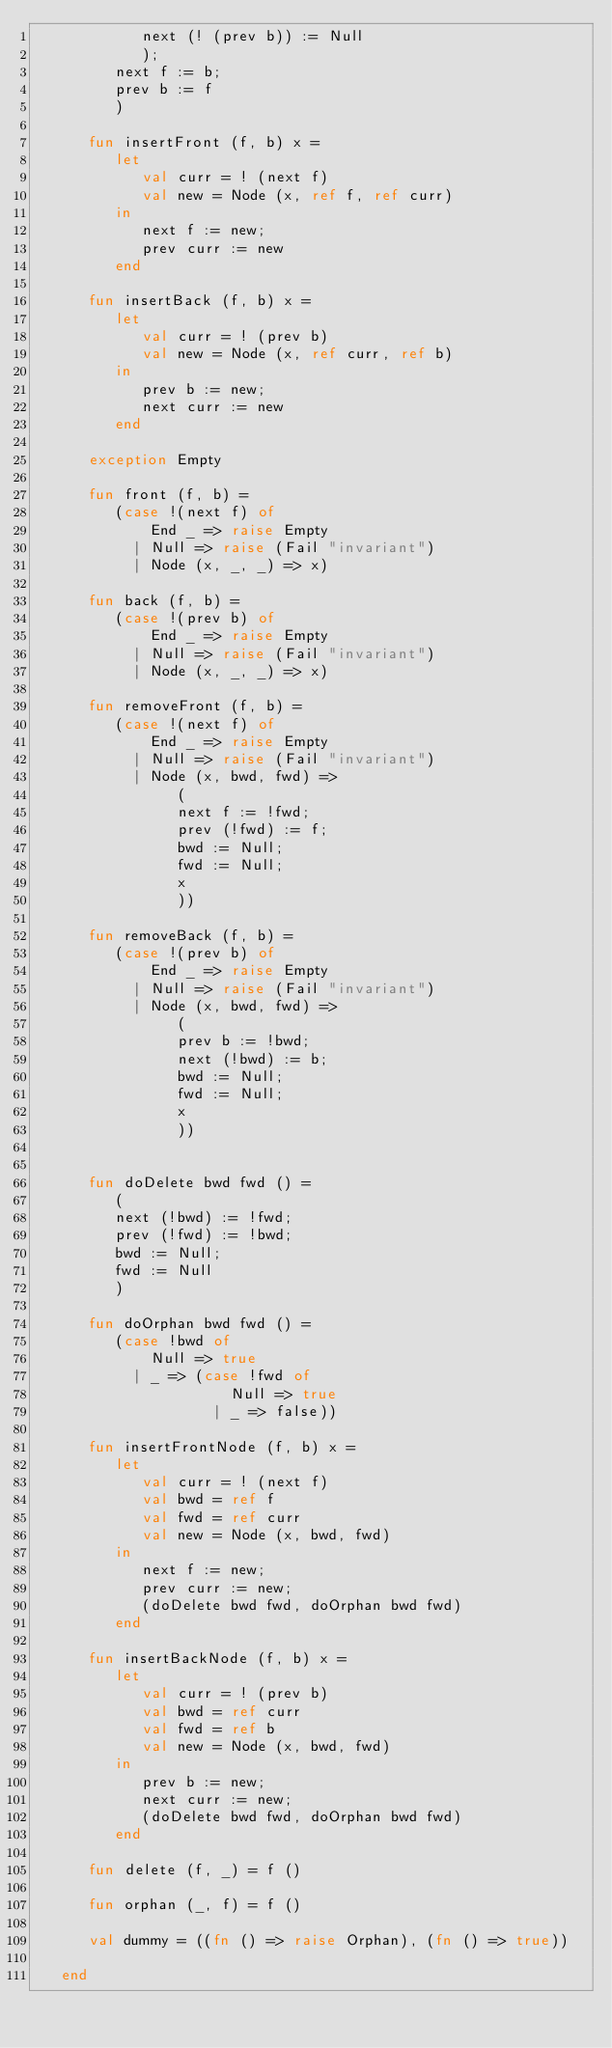<code> <loc_0><loc_0><loc_500><loc_500><_SML_>            next (! (prev b)) := Null
            );
         next f := b;
         prev b := f
         )
         
      fun insertFront (f, b) x =
         let
            val curr = ! (next f)
            val new = Node (x, ref f, ref curr)
         in
            next f := new;
            prev curr := new
         end

      fun insertBack (f, b) x =
         let
            val curr = ! (prev b)
            val new = Node (x, ref curr, ref b)
         in
            prev b := new;
            next curr := new
         end

      exception Empty

      fun front (f, b) =
         (case !(next f) of
             End _ => raise Empty
           | Null => raise (Fail "invariant")
           | Node (x, _, _) => x)

      fun back (f, b) =
         (case !(prev b) of
             End _ => raise Empty
           | Null => raise (Fail "invariant")
           | Node (x, _, _) => x)

      fun removeFront (f, b) =
         (case !(next f) of
             End _ => raise Empty
           | Null => raise (Fail "invariant")
           | Node (x, bwd, fwd) =>
                (
                next f := !fwd;
                prev (!fwd) := f;
                bwd := Null;
                fwd := Null;
                x
                ))

      fun removeBack (f, b) =
         (case !(prev b) of
             End _ => raise Empty
           | Null => raise (Fail "invariant")
           | Node (x, bwd, fwd) =>
                (
                prev b := !bwd;
                next (!bwd) := b;
                bwd := Null;
                fwd := Null;
                x
                ))


      fun doDelete bwd fwd () =
         (
         next (!bwd) := !fwd;
         prev (!fwd) := !bwd;
         bwd := Null;
         fwd := Null
         )

      fun doOrphan bwd fwd () =
         (case !bwd of
             Null => true
           | _ => (case !fwd of
                      Null => true
                    | _ => false))

      fun insertFrontNode (f, b) x =
         let
            val curr = ! (next f)
            val bwd = ref f
            val fwd = ref curr
            val new = Node (x, bwd, fwd)
         in
            next f := new;
            prev curr := new;
            (doDelete bwd fwd, doOrphan bwd fwd)
         end

      fun insertBackNode (f, b) x =
         let
            val curr = ! (prev b)
            val bwd = ref curr
            val fwd = ref b
            val new = Node (x, bwd, fwd)
         in
            prev b := new;
            next curr := new;
            (doDelete bwd fwd, doOrphan bwd fwd)
         end

      fun delete (f, _) = f ()

      fun orphan (_, f) = f ()

      val dummy = ((fn () => raise Orphan), (fn () => true))

   end
</code> 